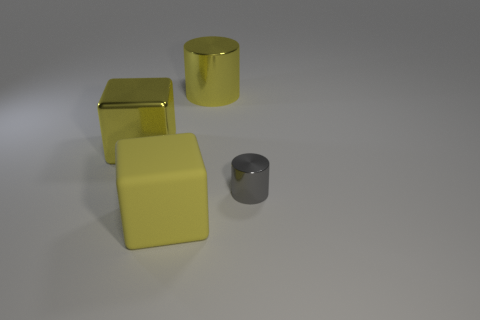Add 1 big brown metallic spheres. How many objects exist? 5 Subtract all small purple objects. Subtract all metallic cylinders. How many objects are left? 2 Add 1 big yellow cylinders. How many big yellow cylinders are left? 2 Add 3 large yellow matte cylinders. How many large yellow matte cylinders exist? 3 Subtract 0 red balls. How many objects are left? 4 